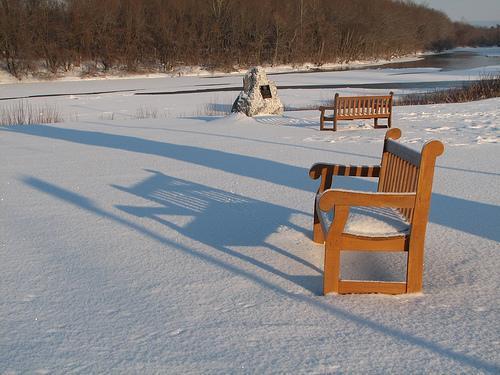How many dolphins are painted on the boats in this photo?
Give a very brief answer. 0. 